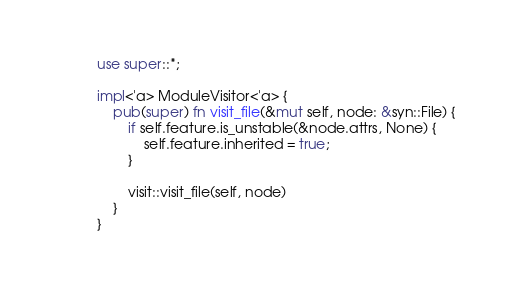Convert code to text. <code><loc_0><loc_0><loc_500><loc_500><_Rust_>use super::*;

impl<'a> ModuleVisitor<'a> {
    pub(super) fn visit_file(&mut self, node: &syn::File) {
        if self.feature.is_unstable(&node.attrs, None) {
            self.feature.inherited = true;
        }

        visit::visit_file(self, node)
    }
}
</code> 